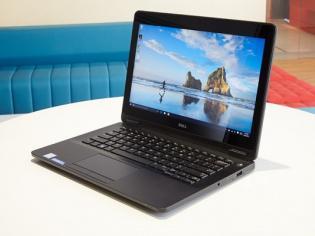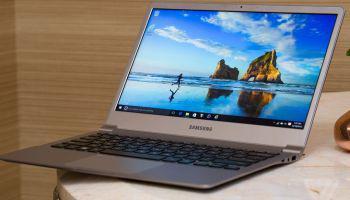The first image is the image on the left, the second image is the image on the right. Analyze the images presented: Is the assertion "One image contains twice as many laptops as the other image, and the other image features a rightward-facing laptop with a blue-and-green wave on its screen." valid? Answer yes or no. No. The first image is the image on the left, the second image is the image on the right. Given the left and right images, does the statement "The left and right image contains the same number of laptops." hold true? Answer yes or no. Yes. 